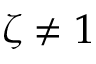Convert formula to latex. <formula><loc_0><loc_0><loc_500><loc_500>\zeta \neq 1</formula> 